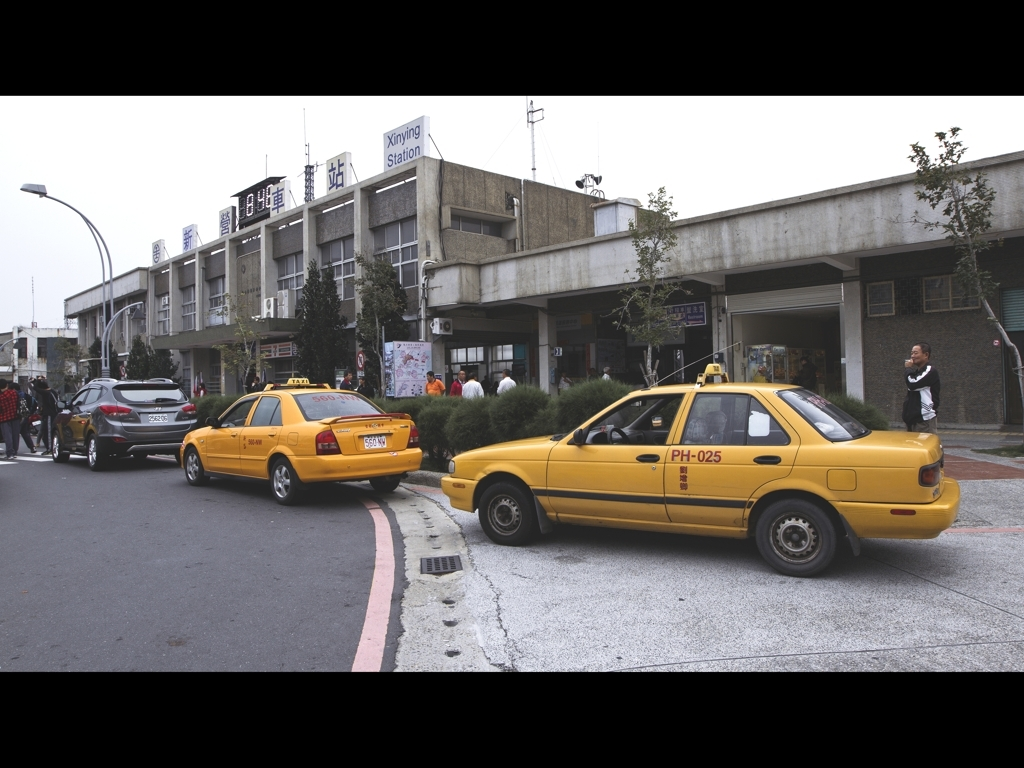What could be the significance of the depicted transportation mode in the local economy? Taxicabs are a key part of urban transportation networks, providing flexible, point-to-point service that complements public transit like the trains at Xinying Station. They likely play a vital role in the local economy by facilitating mobility for residents and tourists, easing traffic congestion, and providing employment opportunities. The proximity of the taxis to the train station also suggests an integrated transport system, which is crucial for the economic vitality of the area. Could there be any environmental implications related to this scene? Certainly, the use of taxicabs contributes to the overall environmental footprint of transportation, including emissions of greenhouse gases and other pollutants. The congestion of taxis, especially if idling, can lead to increased air pollution in the area. On a positive note, the presence of a train station indicates the availability of public transit, which can reduce the environmental impact by offering a more sustainable alternative to individual car use. 